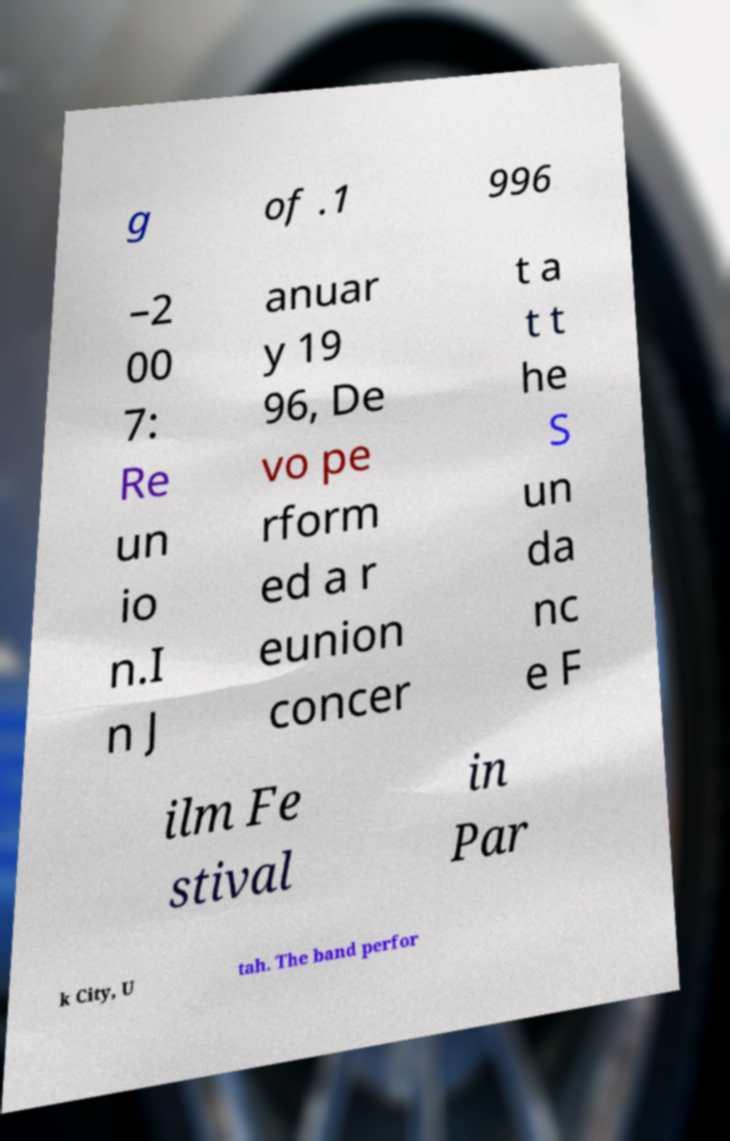Please read and relay the text visible in this image. What does it say? g of .1 996 –2 00 7: Re un io n.I n J anuar y 19 96, De vo pe rform ed a r eunion concer t a t t he S un da nc e F ilm Fe stival in Par k City, U tah. The band perfor 